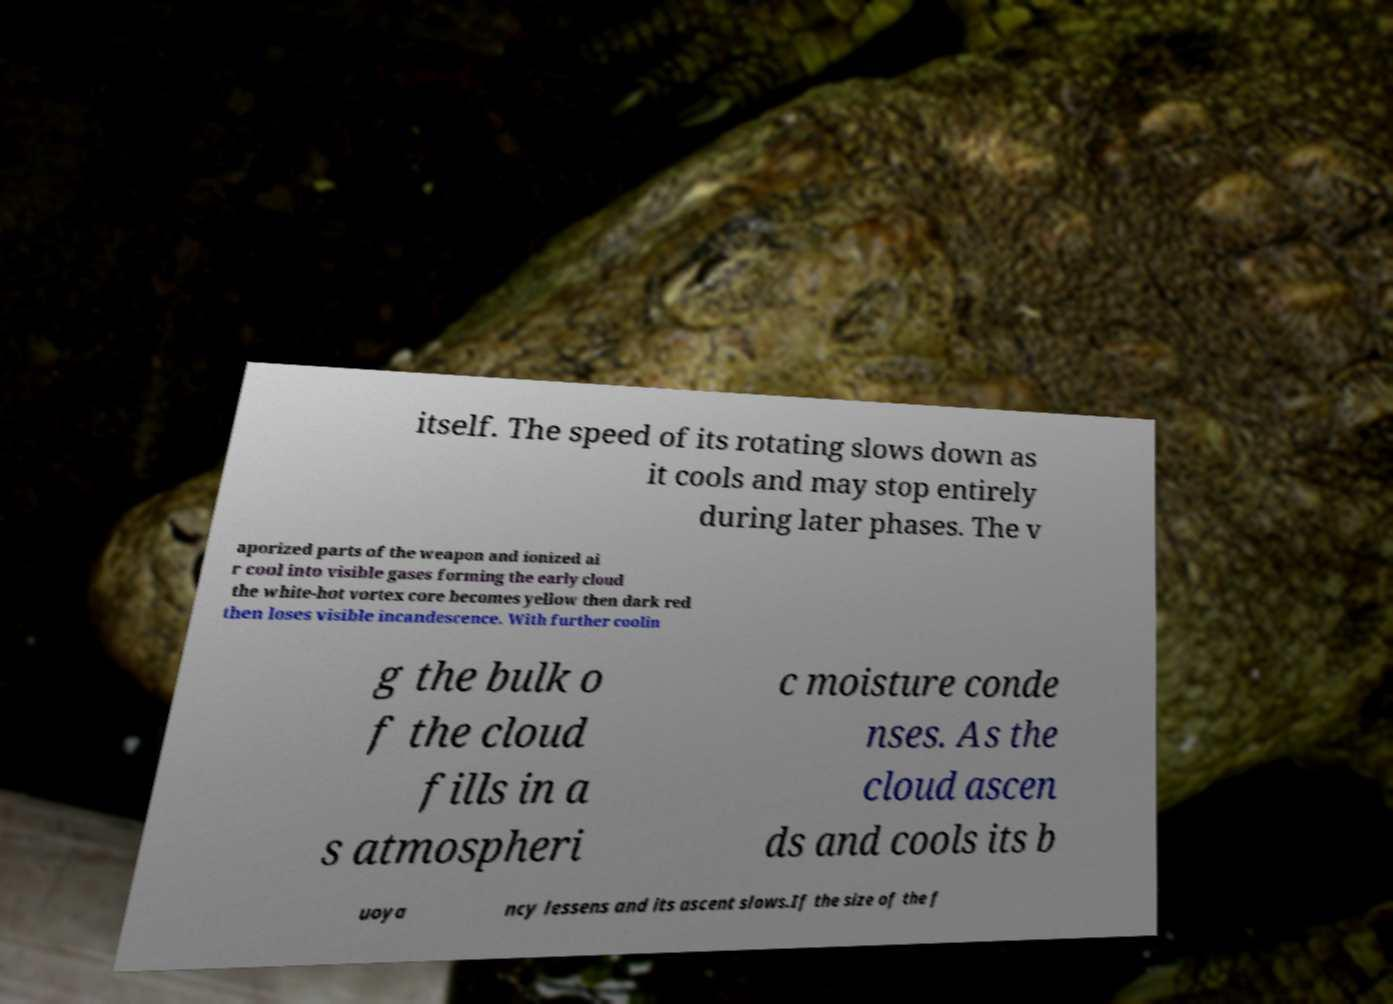Could you assist in decoding the text presented in this image and type it out clearly? itself. The speed of its rotating slows down as it cools and may stop entirely during later phases. The v aporized parts of the weapon and ionized ai r cool into visible gases forming the early cloud the white-hot vortex core becomes yellow then dark red then loses visible incandescence. With further coolin g the bulk o f the cloud fills in a s atmospheri c moisture conde nses. As the cloud ascen ds and cools its b uoya ncy lessens and its ascent slows.If the size of the f 